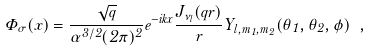<formula> <loc_0><loc_0><loc_500><loc_500>\Phi _ { \sigma } ( x ) = \frac { { \sqrt { q } } } { \alpha ^ { 3 / 2 } ( 2 \pi ) ^ { 2 } } e ^ { - i k x } \frac { J _ { \nu _ { l } } ( q r ) } r Y _ { l , m _ { 1 } , m _ { 2 } } ( \theta _ { 1 } , \theta _ { 2 } , \phi ) \ ,</formula> 